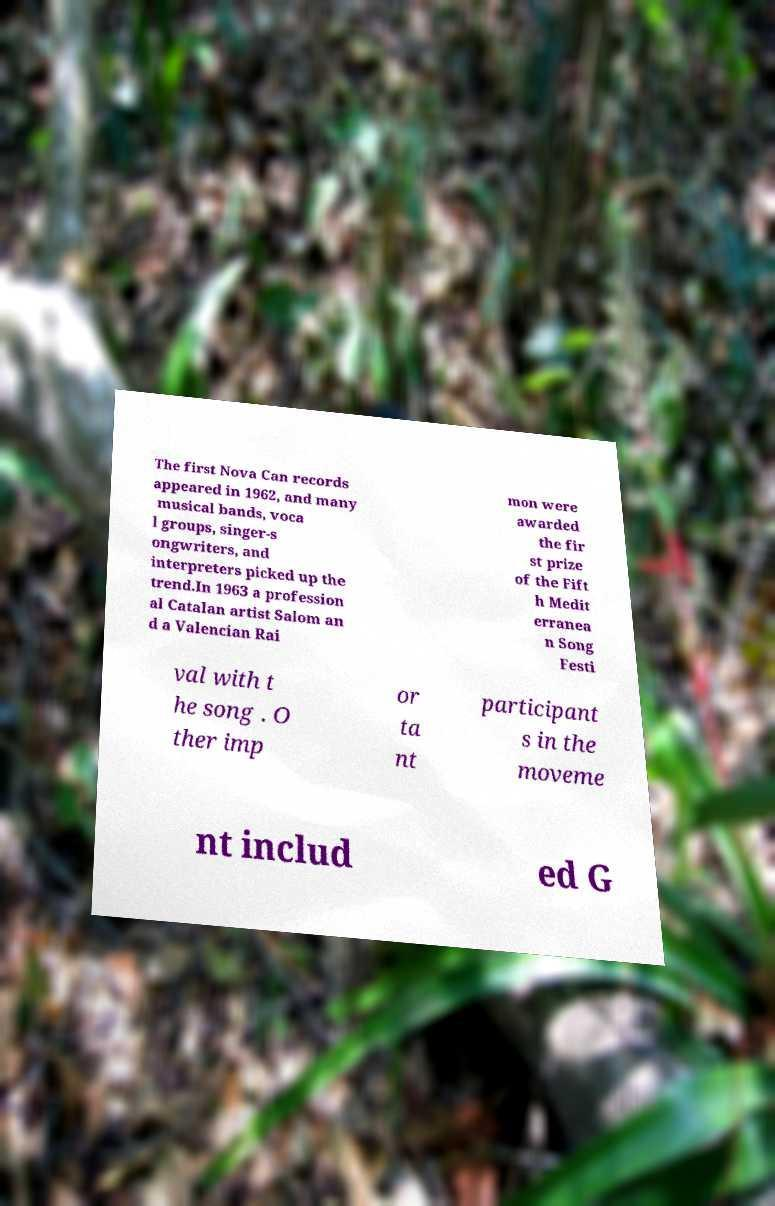Could you extract and type out the text from this image? The first Nova Can records appeared in 1962, and many musical bands, voca l groups, singer-s ongwriters, and interpreters picked up the trend.In 1963 a profession al Catalan artist Salom an d a Valencian Rai mon were awarded the fir st prize of the Fift h Medit erranea n Song Festi val with t he song . O ther imp or ta nt participant s in the moveme nt includ ed G 